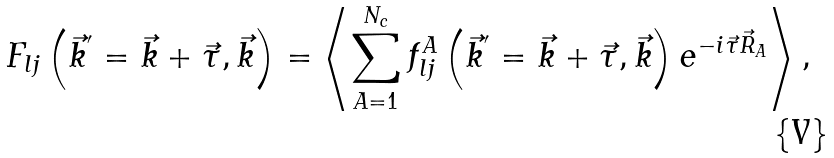Convert formula to latex. <formula><loc_0><loc_0><loc_500><loc_500>F _ { l j } \left ( \vec { k } ^ { ^ { \prime } } = \vec { k } + \vec { \tau } , \vec { k } \right ) = \left \langle \sum _ { A = 1 } ^ { N _ { c } } f _ { l j } ^ { A } \left ( \vec { k } ^ { ^ { \prime } } = \vec { k } + \vec { \tau } , \vec { k } \right ) e ^ { - i \vec { \tau } \vec { R } _ { A } } \right \rangle ,</formula> 